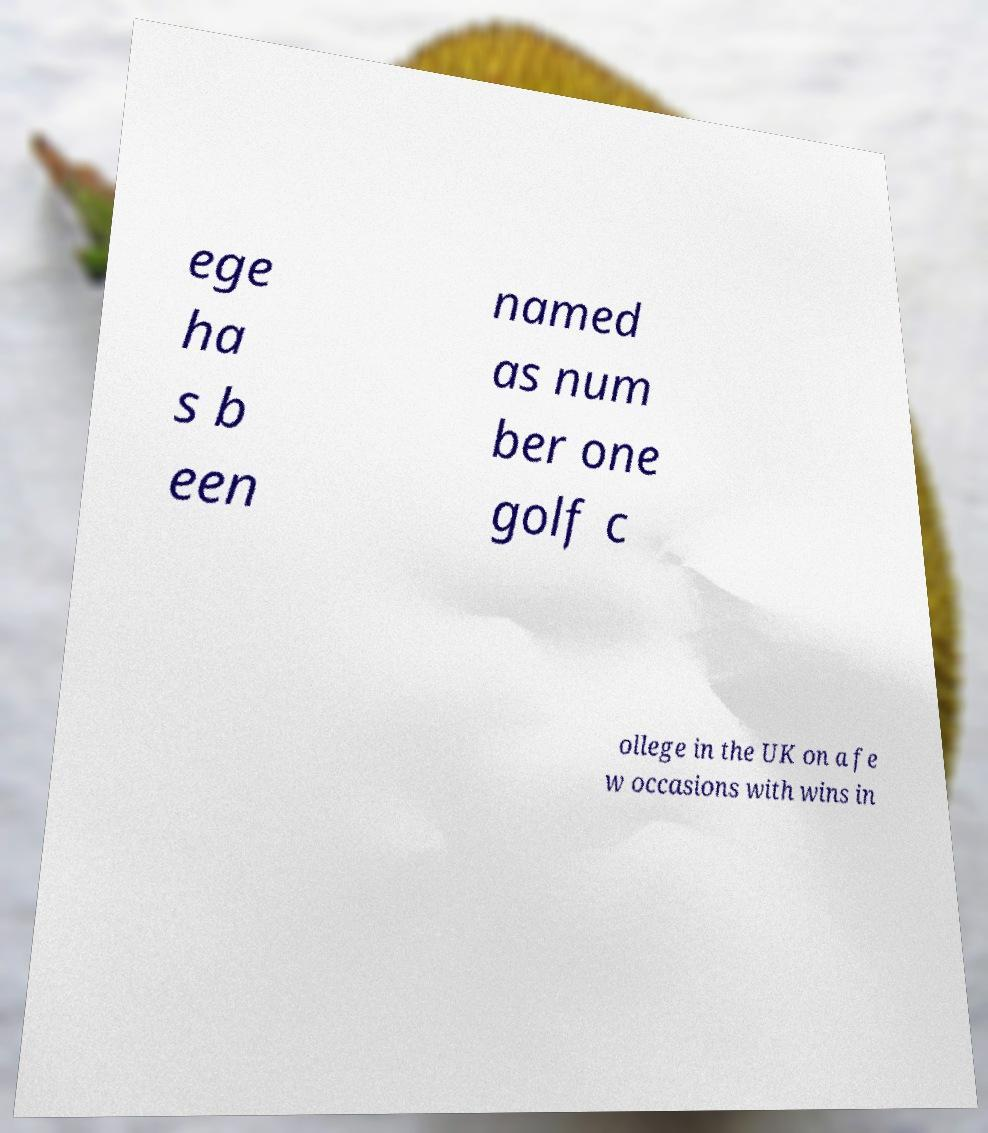I need the written content from this picture converted into text. Can you do that? ege ha s b een named as num ber one golf c ollege in the UK on a fe w occasions with wins in 